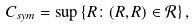Convert formula to latex. <formula><loc_0><loc_0><loc_500><loc_500>C _ { s y m } = \sup \left \{ R \colon ( R , R ) \in \mathcal { R } \right \} ,</formula> 